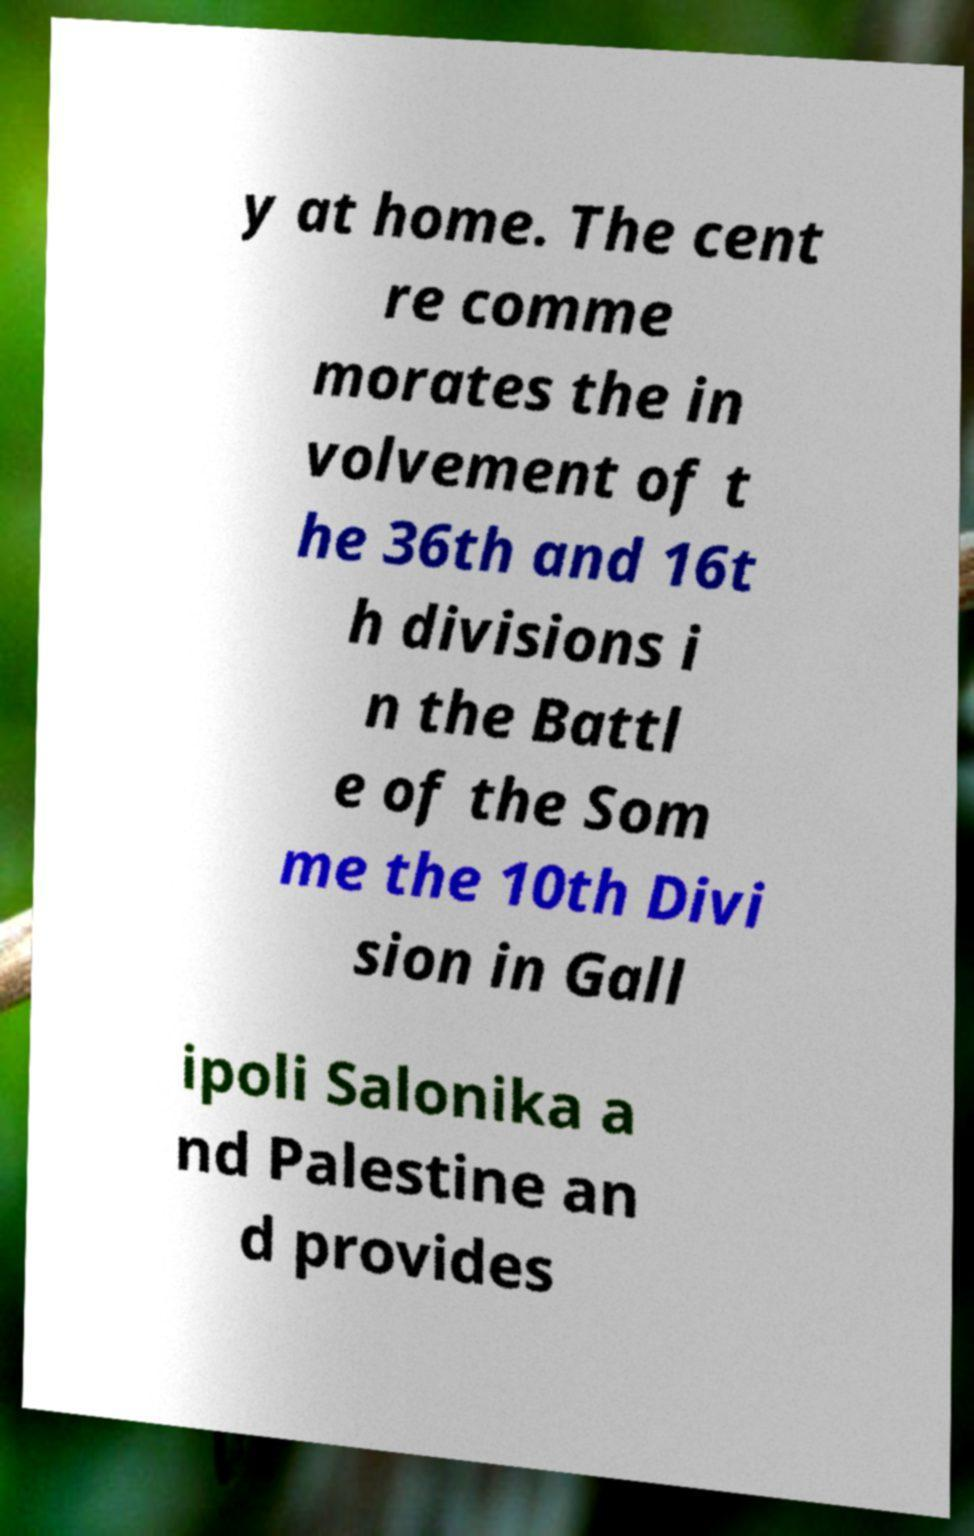Please read and relay the text visible in this image. What does it say? y at home. The cent re comme morates the in volvement of t he 36th and 16t h divisions i n the Battl e of the Som me the 10th Divi sion in Gall ipoli Salonika a nd Palestine an d provides 